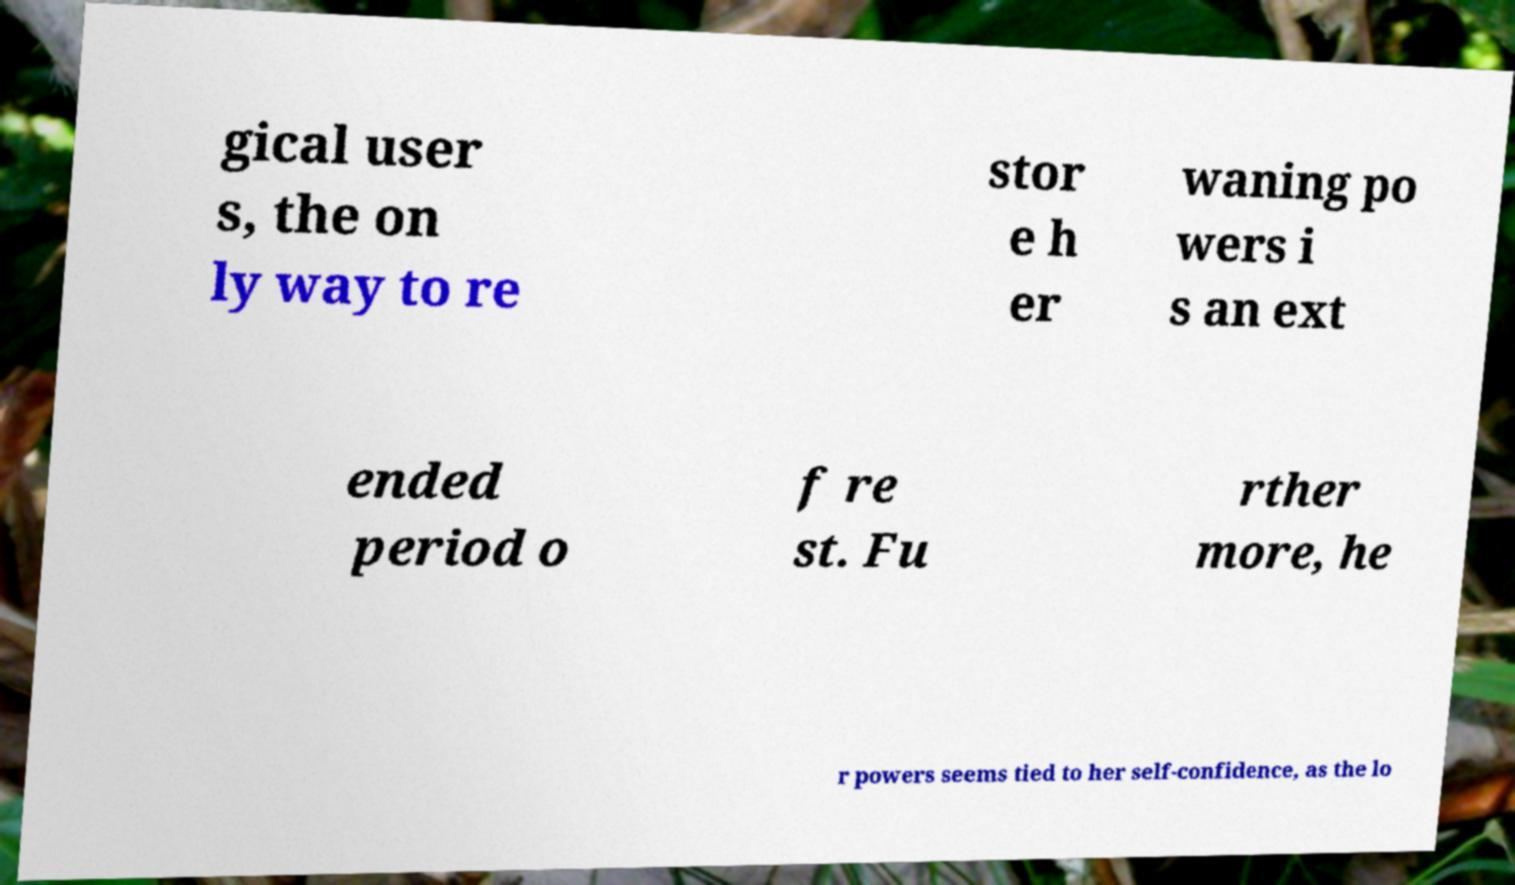For documentation purposes, I need the text within this image transcribed. Could you provide that? gical user s, the on ly way to re stor e h er waning po wers i s an ext ended period o f re st. Fu rther more, he r powers seems tied to her self-confidence, as the lo 